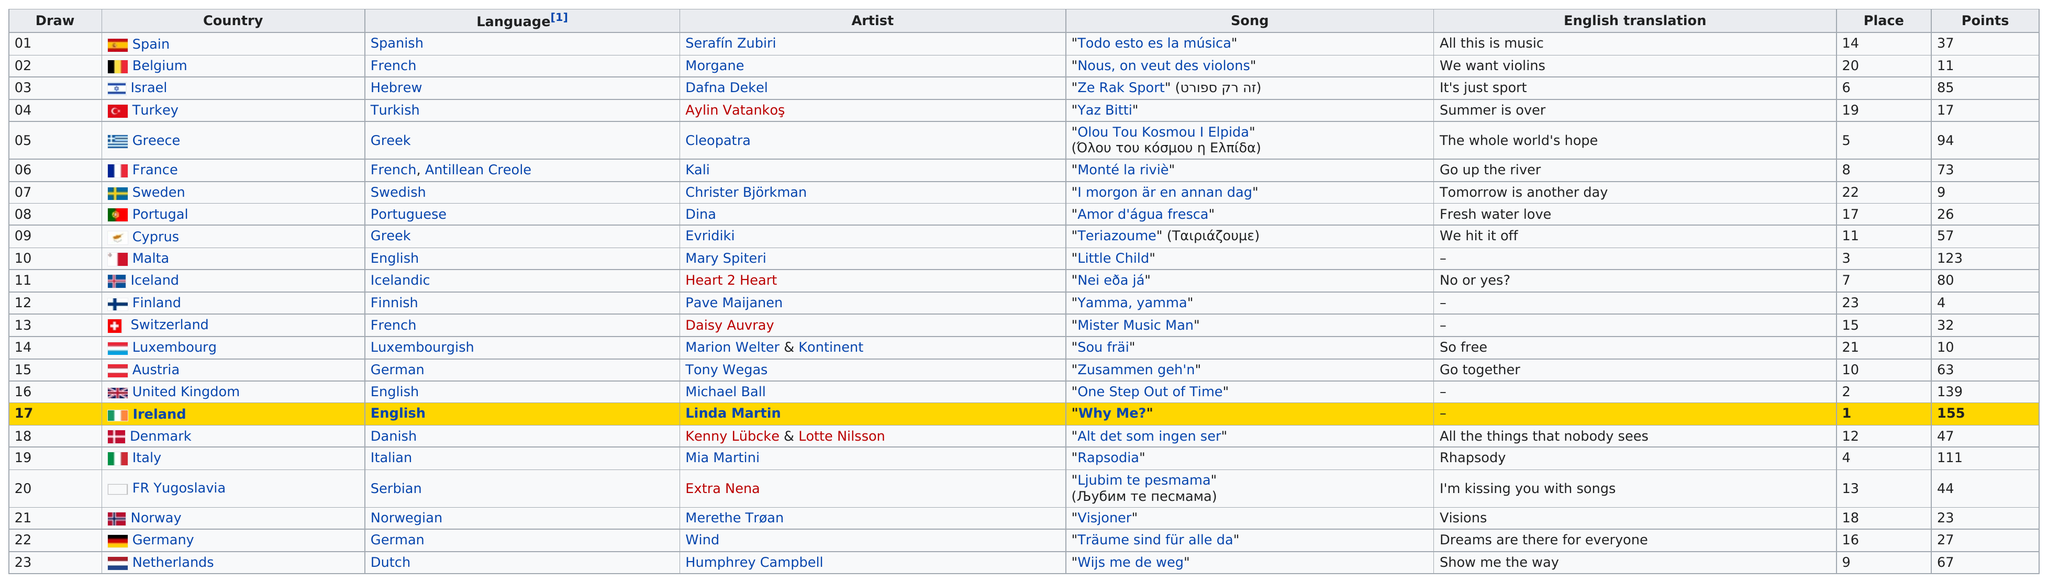Mention a couple of crucial points in this snapshot. Out of the total number of artists who scored at least 40 points, 13 artists were identified. Finland has scored 4 points in total. The song by the artist from France resulted in the highest score, whereas the song by the artist from Spain did not score as high. Belgium succeeded Spain as the country located on the table. After the first round of competition, the United Kingdom earned the most points, making it the country with the best performance. 